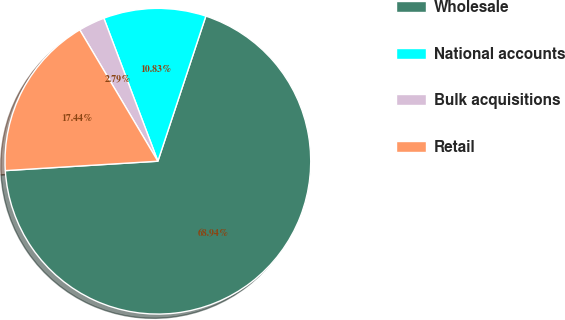Convert chart. <chart><loc_0><loc_0><loc_500><loc_500><pie_chart><fcel>Wholesale<fcel>National accounts<fcel>Bulk acquisitions<fcel>Retail<nl><fcel>68.94%<fcel>10.83%<fcel>2.79%<fcel>17.44%<nl></chart> 